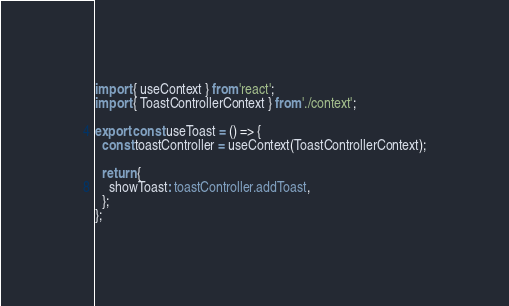<code> <loc_0><loc_0><loc_500><loc_500><_TypeScript_>import { useContext } from 'react';
import { ToastControllerContext } from './context';

export const useToast = () => {
  const toastController = useContext(ToastControllerContext);

  return {
    showToast: toastController.addToast,
  };
};
</code> 